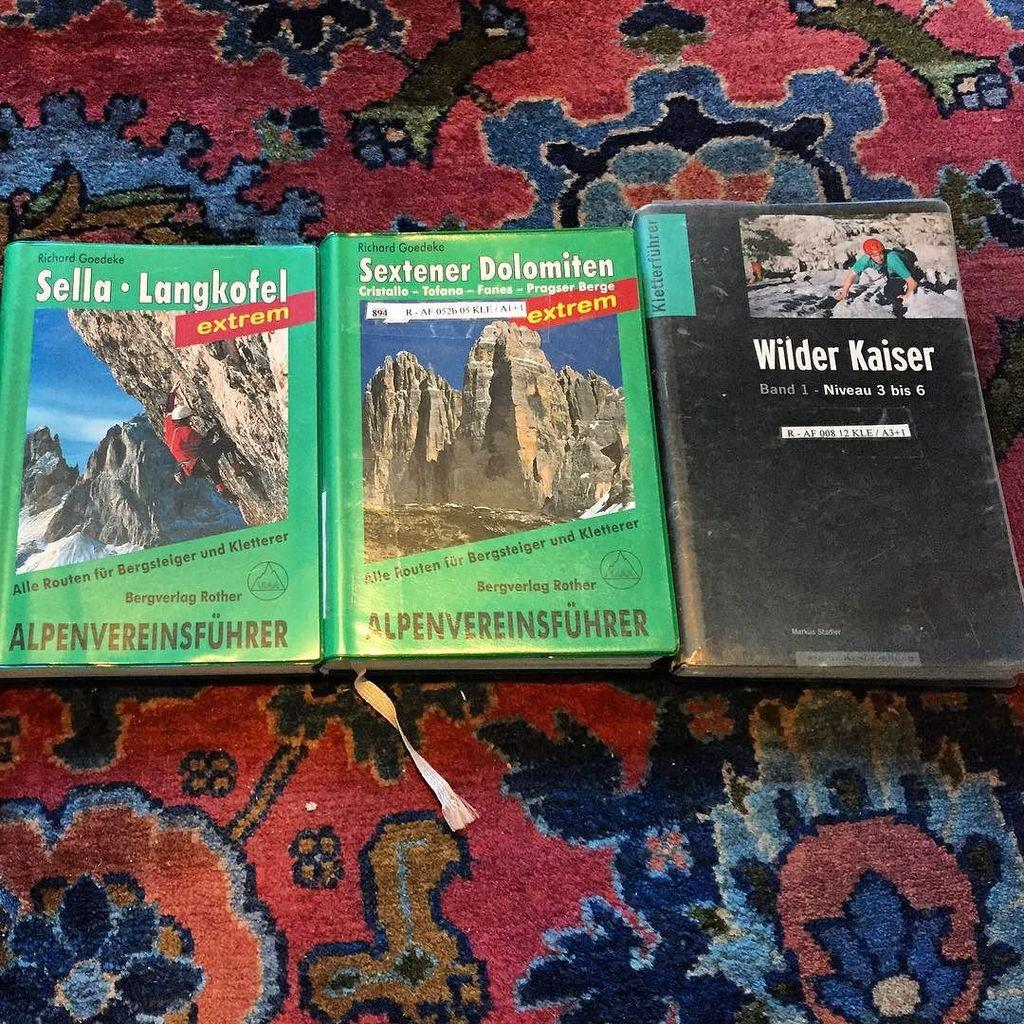Provide a one-sentence caption for the provided image. The last 4 characters on the identification label, Wilder Kaiser book, is A3+1. 